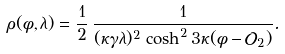Convert formula to latex. <formula><loc_0><loc_0><loc_500><loc_500>\rho ( \phi , \lambda ) = \frac { 1 } { 2 } \, \frac { 1 } { ( \kappa \gamma \lambda ) ^ { 2 } \, \cosh ^ { 2 } 3 \kappa ( \phi - \mathcal { O } _ { 2 } ) } .</formula> 